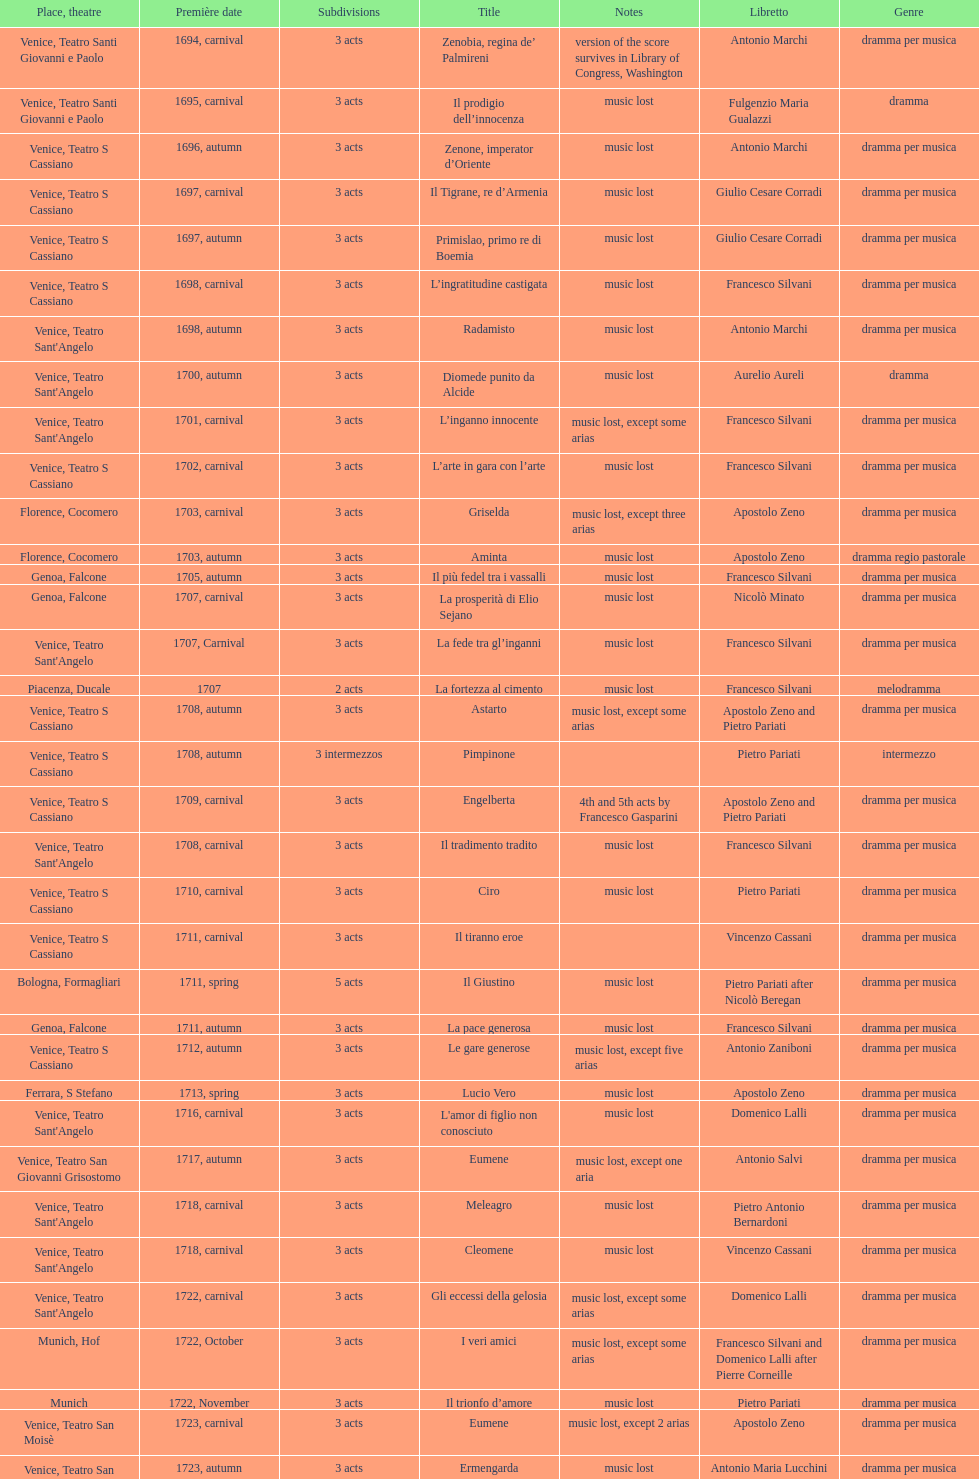Which opera has at least 5 acts? Il Giustino. 